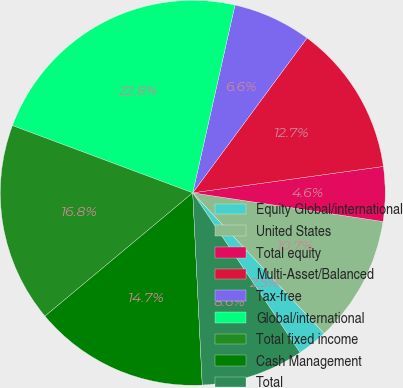Convert chart to OTSL. <chart><loc_0><loc_0><loc_500><loc_500><pie_chart><fcel>Equity Global/international<fcel>United States<fcel>Total equity<fcel>Multi-Asset/Balanced<fcel>Tax-free<fcel>Global/international<fcel>Total fixed income<fcel>Cash Management<fcel>Total<nl><fcel>2.54%<fcel>10.66%<fcel>4.57%<fcel>12.69%<fcel>6.6%<fcel>22.84%<fcel>16.75%<fcel>14.72%<fcel>8.63%<nl></chart> 